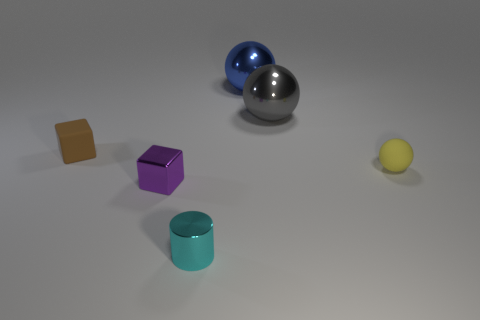Subtract all gray balls. How many balls are left? 2 Add 1 blocks. How many objects exist? 7 Subtract all cylinders. How many objects are left? 5 Subtract all cyan balls. Subtract all gray cylinders. How many balls are left? 3 Subtract all tiny cyan metal objects. Subtract all small objects. How many objects are left? 1 Add 5 tiny metallic objects. How many tiny metallic objects are left? 7 Add 3 cyan shiny balls. How many cyan shiny balls exist? 3 Subtract 1 purple blocks. How many objects are left? 5 